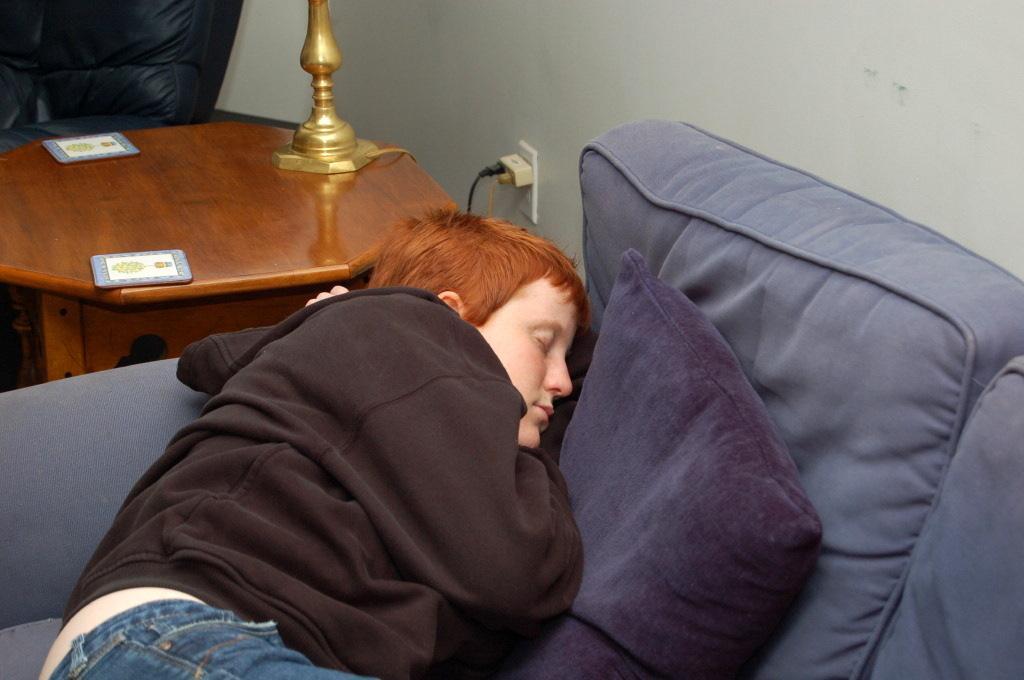Could you give a brief overview of what you see in this image? In the middle of the picture we can see a person sleeping on the sofa, there's even a pillow, purple in color. Beside the sofa there is a table, on the table there are other objects. This is a switchboard and a wall. 